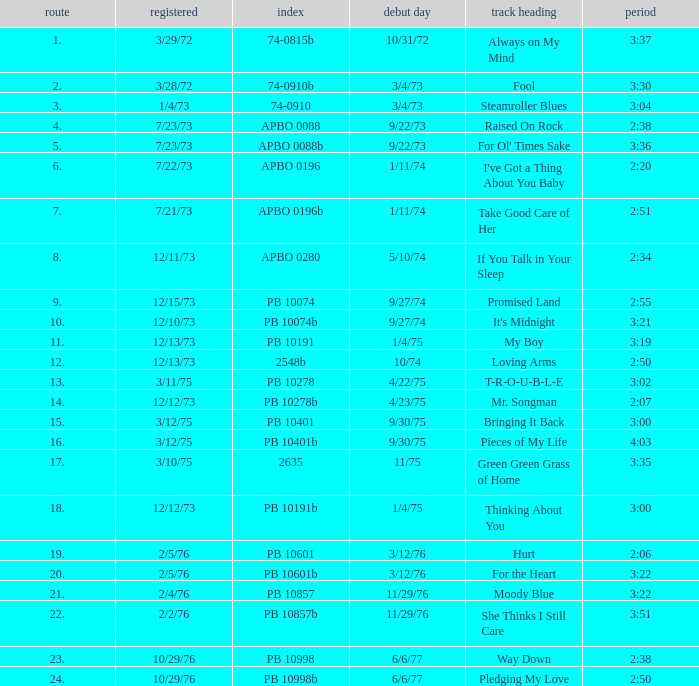Tell me the recorded for time of 2:50 and released date of 6/6/77 with track more than 20 10/29/76. 